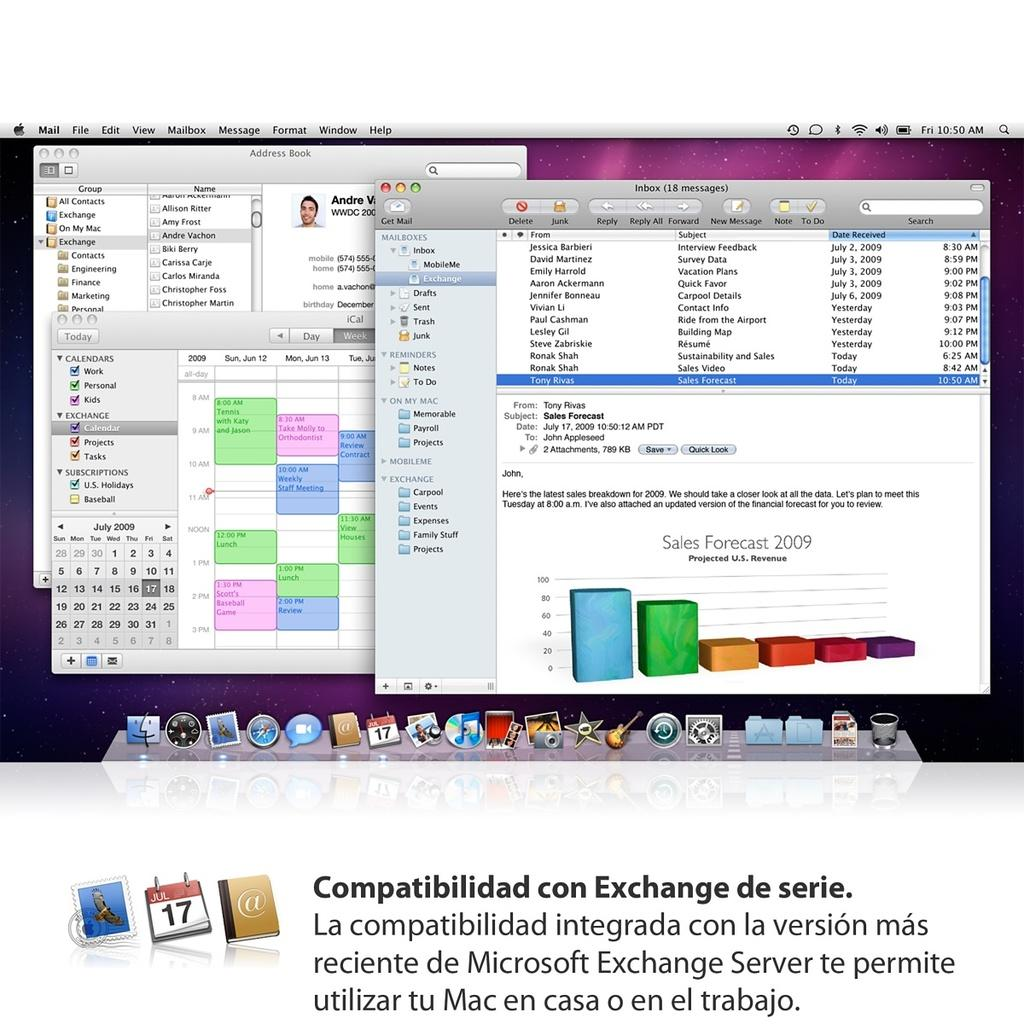<image>
Write a terse but informative summary of the picture. a screen of a computer with an open email to JOHN about SALES 